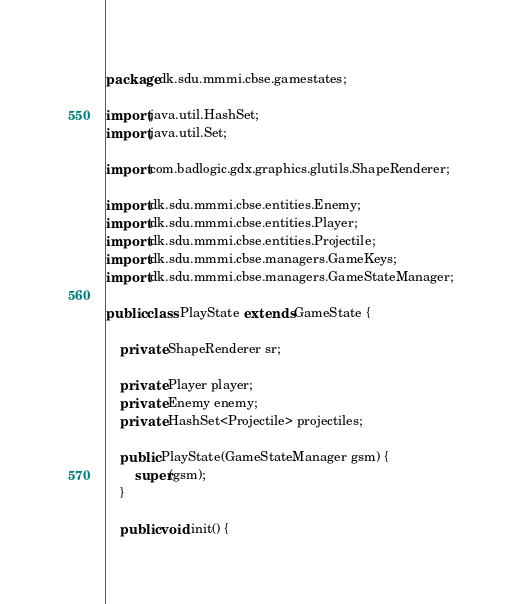<code> <loc_0><loc_0><loc_500><loc_500><_Java_>package dk.sdu.mmmi.cbse.gamestates;

import java.util.HashSet;
import java.util.Set;

import com.badlogic.gdx.graphics.glutils.ShapeRenderer;

import dk.sdu.mmmi.cbse.entities.Enemy;
import dk.sdu.mmmi.cbse.entities.Player;
import dk.sdu.mmmi.cbse.entities.Projectile;
import dk.sdu.mmmi.cbse.managers.GameKeys;
import dk.sdu.mmmi.cbse.managers.GameStateManager;

public class PlayState extends GameState {
	
	private ShapeRenderer sr;
	
	private Player player;
	private Enemy enemy;
	private HashSet<Projectile> projectiles;
	
	public PlayState(GameStateManager gsm) {
		super(gsm);
	}
	
	public void init() {</code> 